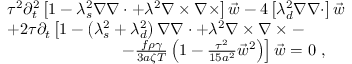Convert formula to latex. <formula><loc_0><loc_0><loc_500><loc_500>\begin{array} { r l } & { \tau ^ { 2 } \partial _ { t } ^ { 2 } \left [ 1 - \lambda _ { s } ^ { 2 } \nabla \nabla \cdot + \lambda ^ { 2 } \nabla \times \nabla \times \right ] \vec { w } - 4 \left [ \lambda _ { d } ^ { 2 } \nabla \nabla \cdot \right ] \vec { w } } \\ & { + 2 \tau \partial _ { t } \left [ 1 - \left ( \lambda _ { s } ^ { 2 } + \lambda _ { d } ^ { 2 } \right ) \nabla \nabla \cdot + \lambda ^ { 2 } \nabla \times \nabla \times - } \\ & { \quad \ - \frac { f \rho \gamma } { 3 a \zeta T } \left ( 1 - \frac { \tau ^ { 2 } } { 1 5 a ^ { 2 } } \vec { w } ^ { 2 } \right ) \right ] \vec { w } = 0 \ , } \end{array}</formula> 